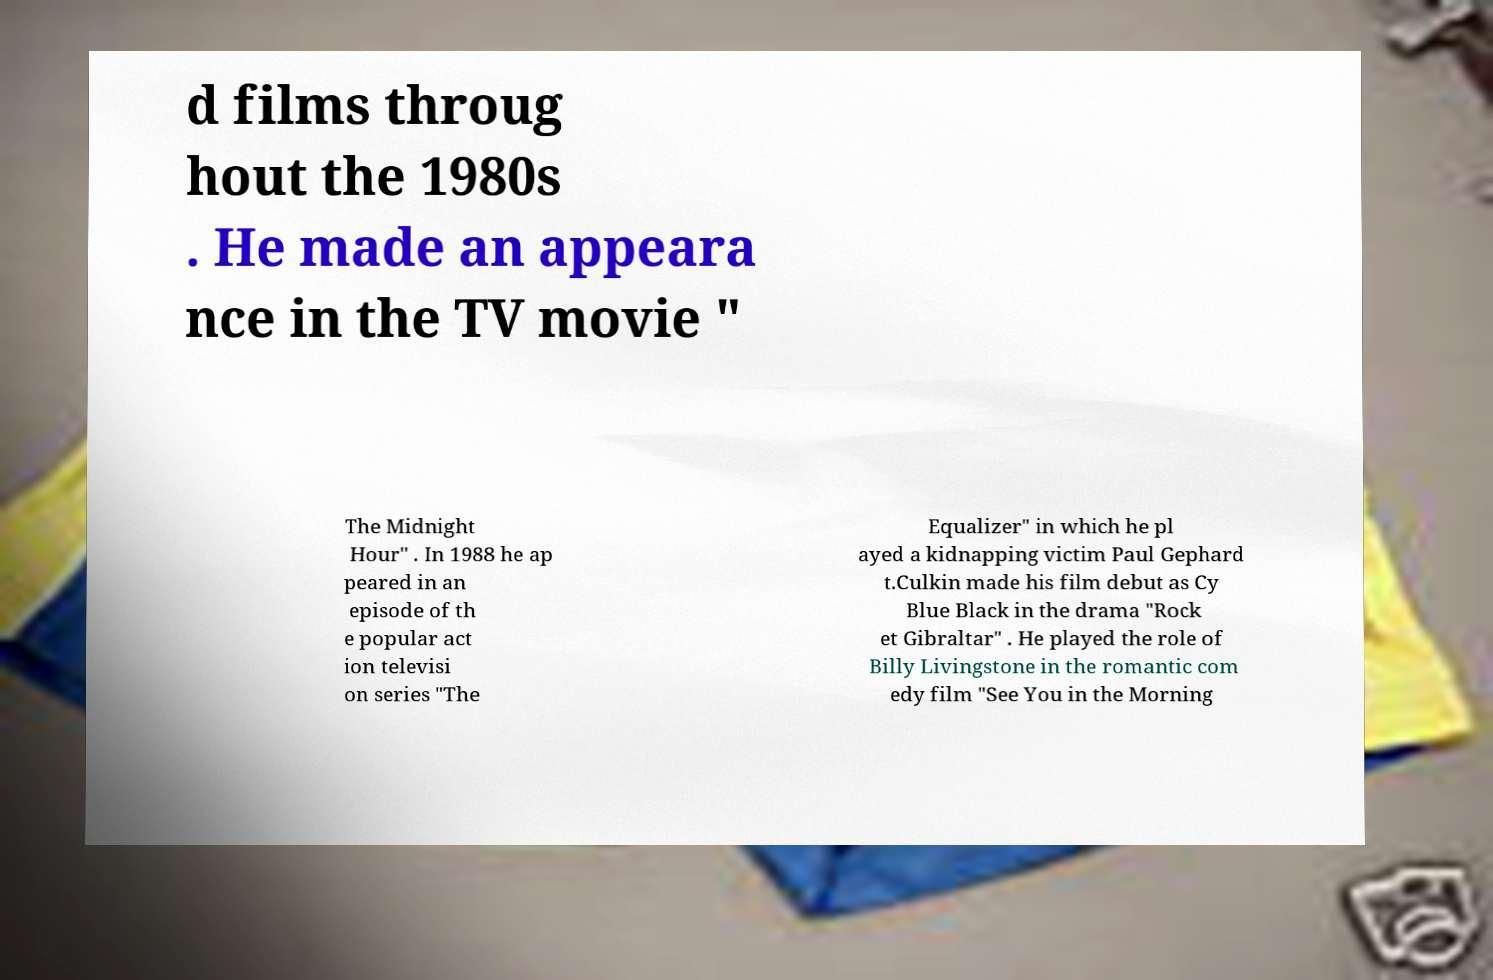Can you read and provide the text displayed in the image?This photo seems to have some interesting text. Can you extract and type it out for me? d films throug hout the 1980s . He made an appeara nce in the TV movie " The Midnight Hour" . In 1988 he ap peared in an episode of th e popular act ion televisi on series "The Equalizer" in which he pl ayed a kidnapping victim Paul Gephard t.Culkin made his film debut as Cy Blue Black in the drama "Rock et Gibraltar" . He played the role of Billy Livingstone in the romantic com edy film "See You in the Morning 